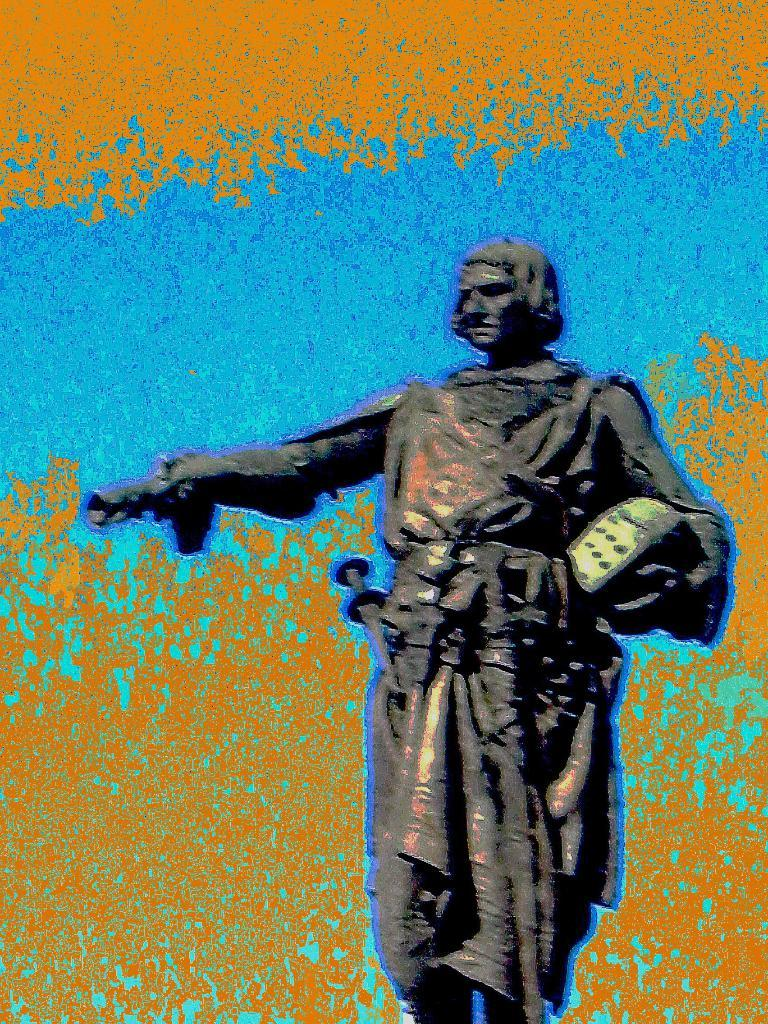What type of editing has been done to the image? The image is edited, but the specific type of editing is not mentioned in the facts. What can be seen in the foreground of the image? There is a statue in the image. What colors are present in the background of the image? The background of the image is yellow and blue in color. How many cars are parked near the statue in the image? There is no mention of cars in the image, as the facts only mention a statue and the background colors. 